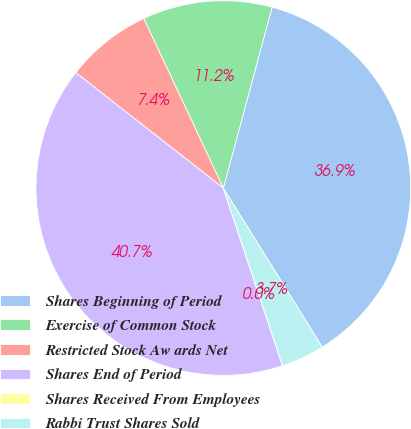Convert chart. <chart><loc_0><loc_0><loc_500><loc_500><pie_chart><fcel>Shares Beginning of Period<fcel>Exercise of Common Stock<fcel>Restricted Stock Aw ards Net<fcel>Shares End of Period<fcel>Shares Received From Employees<fcel>Rabbi Trust Shares Sold<nl><fcel>36.95%<fcel>11.18%<fcel>7.45%<fcel>40.68%<fcel>0.01%<fcel>3.73%<nl></chart> 